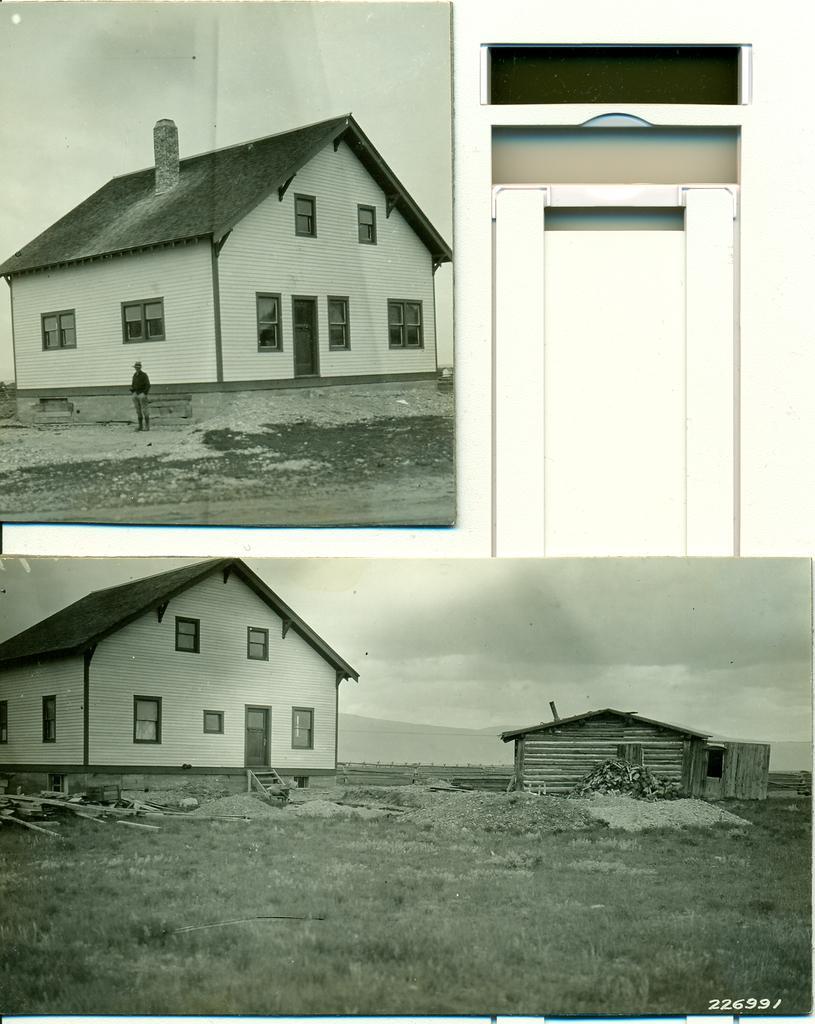Could you give a brief overview of what you see in this image? It is the collage of two images. In this image there is a house on the ground. Beside the house there is a small hut. On the ground there is grass and sand. Beside the house there are wooden sticks on the ground. At the top there is sky. Beside the house there is a man standing on the ground. 